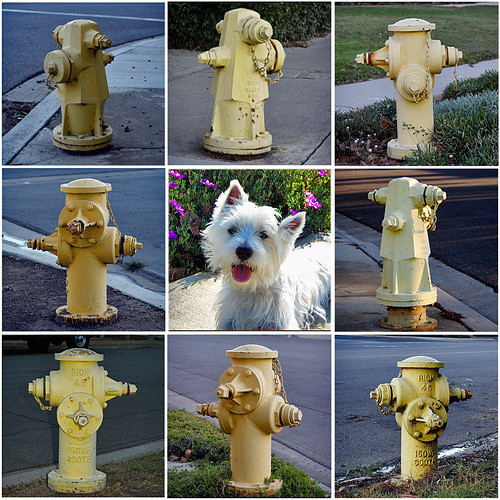<image>Which fire hydrant is most common? It is ambiguous which fire hydrant is most common. Which fire hydrant is most common? I am not sure which fire hydrant is most common. It can be any of them. 